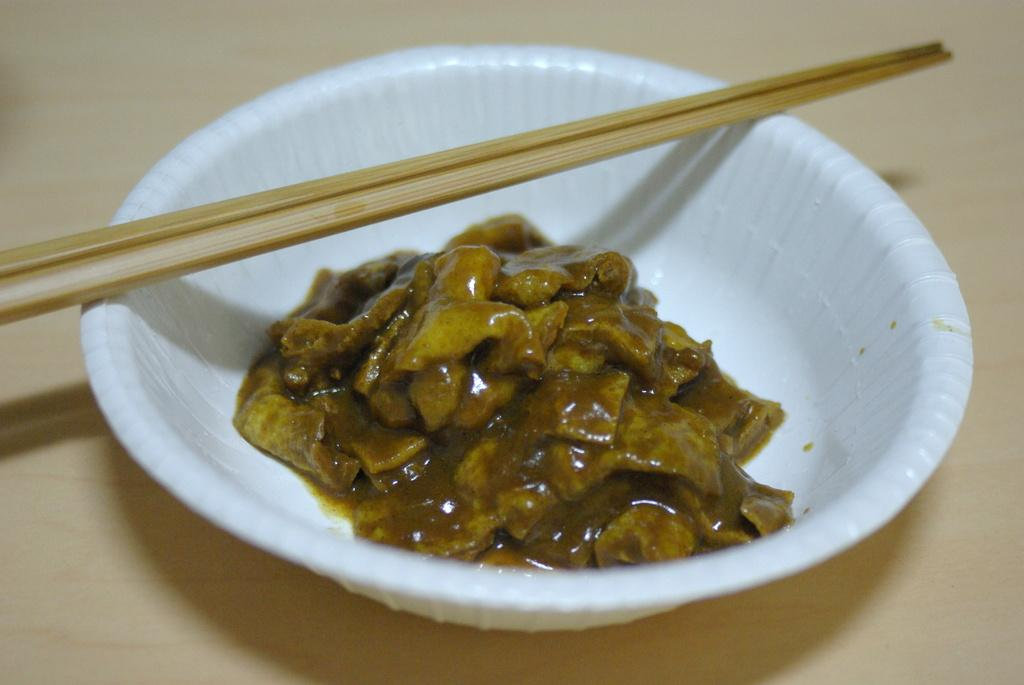What is the color of the plate in the image? The plate in the image is white. Where is the plate located in the image? The plate is on a surface in the image. What is on top of the plate? There is a food item and chopsticks on the plate. What type of bells can be heard ringing in the image? There are no bells present in the image, and therefore no sounds can be heard. 